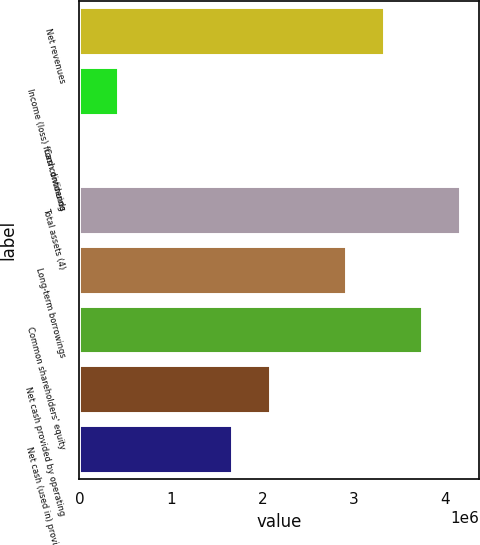Convert chart. <chart><loc_0><loc_0><loc_500><loc_500><bar_chart><fcel>Net revenues<fcel>Income (loss) from continuing<fcel>Cash dividends<fcel>Total assets (4)<fcel>Long-term borrowings<fcel>Common shareholders' equity<fcel>Net cash provided by operating<fcel>Net cash (used in) provided by<nl><fcel>3.32732e+06<fcel>415916<fcel>1.36<fcel>4.15915e+06<fcel>2.9114e+06<fcel>3.74323e+06<fcel>2.07957e+06<fcel>1.66366e+06<nl></chart> 